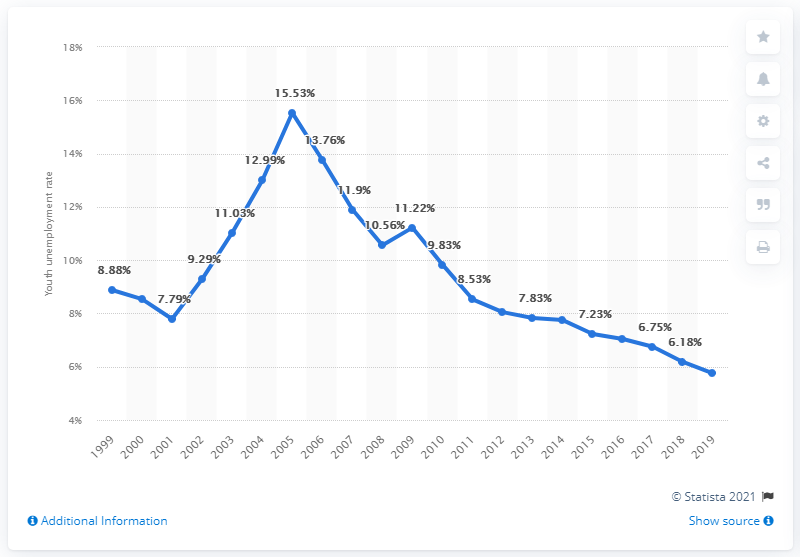Highlight a few significant elements in this photo. In 2019, the youth unemployment rate in Germany was 5.75%. 